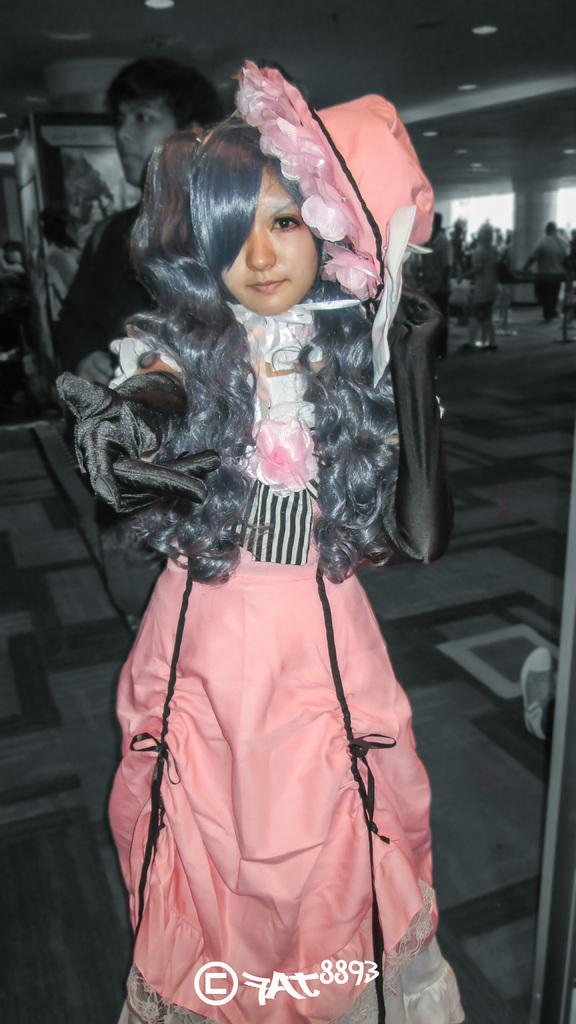What is the main subject of the image? There is a woman standing in the image. Can you describe the background of the image? There are people visible in the background of the image, and there is a floor. What is located at the top of the image? Lights are present at the top of the image. What is the woman's income in the image? There is no information about the woman's income in the image. Is there a road visible in the image? There is no road visible in the image. 